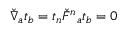<formula> <loc_0><loc_0><loc_500><loc_500>\check { \nabla } _ { a } t _ { b } = t _ { n } \check { F ^ { n _ { a } t _ { b } = 0</formula> 